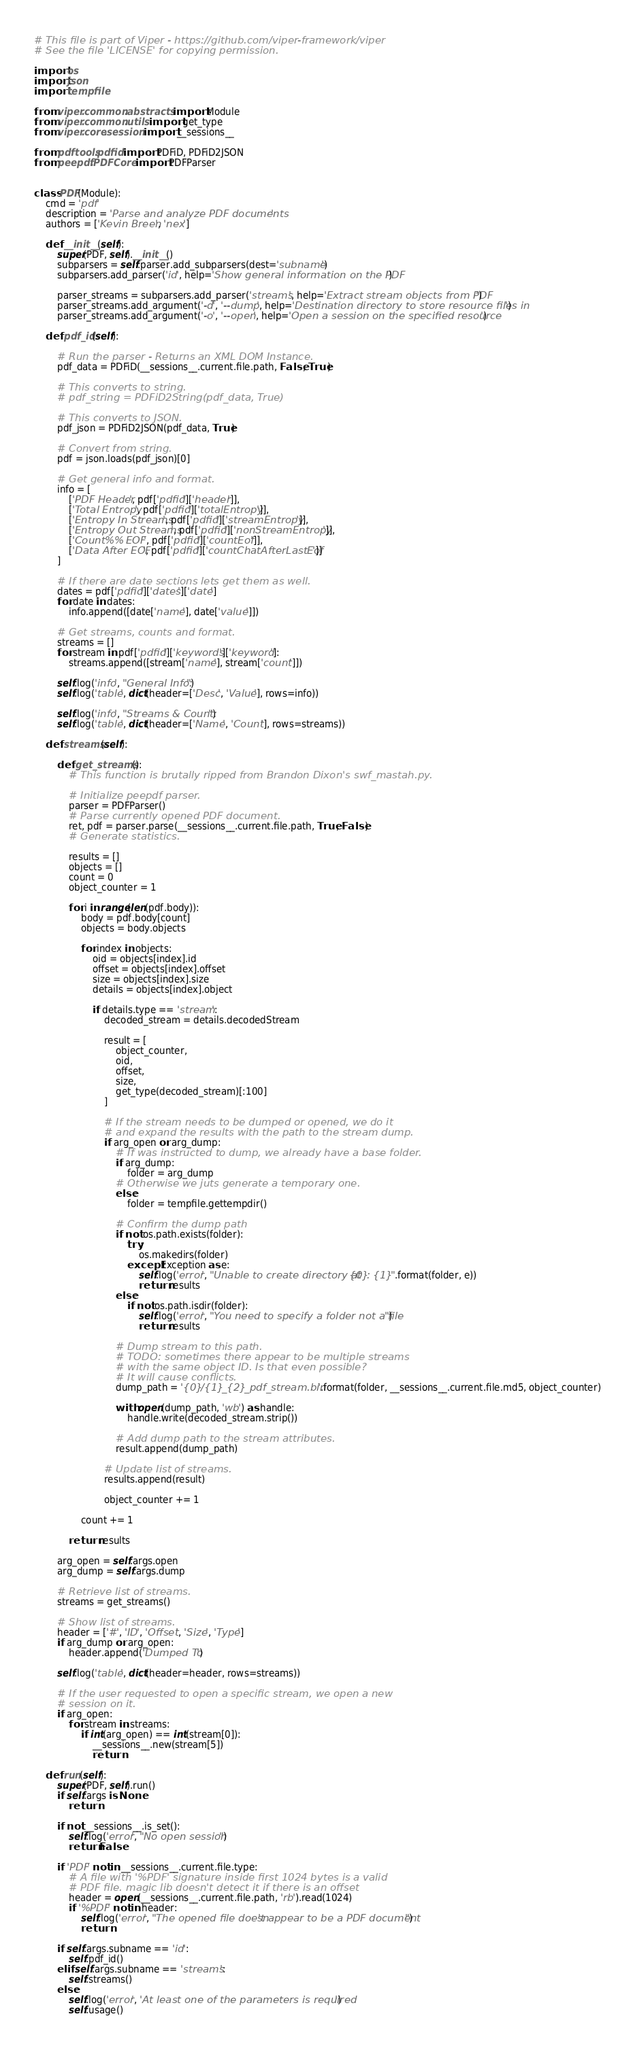Convert code to text. <code><loc_0><loc_0><loc_500><loc_500><_Python_># This file is part of Viper - https://github.com/viper-framework/viper
# See the file 'LICENSE' for copying permission.

import os
import json
import tempfile

from viper.common.abstracts import Module
from viper.common.utils import get_type
from viper.core.session import __sessions__

from pdftools.pdfid import PDFiD, PDFiD2JSON
from peepdf.PDFCore import PDFParser


class PDF(Module):
    cmd = 'pdf'
    description = 'Parse and analyze PDF documents'
    authors = ['Kevin Breen', 'nex']

    def __init__(self):
        super(PDF, self).__init__()
        subparsers = self.parser.add_subparsers(dest='subname')
        subparsers.add_parser('id', help='Show general information on the PDF')

        parser_streams = subparsers.add_parser('streams', help='Extract stream objects from PDF')
        parser_streams.add_argument('-d', '--dump', help='Destination directory to store resource files in')
        parser_streams.add_argument('-o', '--open', help='Open a session on the specified resource')

    def pdf_id(self):

        # Run the parser - Returns an XML DOM Instance.
        pdf_data = PDFiD(__sessions__.current.file.path, False, True)

        # This converts to string.
        # pdf_string = PDFiD2String(pdf_data, True)

        # This converts to JSON.
        pdf_json = PDFiD2JSON(pdf_data, True)

        # Convert from string.
        pdf = json.loads(pdf_json)[0]

        # Get general info and format.
        info = [
            ['PDF Header', pdf['pdfid']['header']],
            ['Total Entropy', pdf['pdfid']['totalEntropy']],
            ['Entropy In Streams', pdf['pdfid']['streamEntropy']],
            ['Entropy Out Streams', pdf['pdfid']['nonStreamEntropy']],
            ['Count %% EOF', pdf['pdfid']['countEof']],
            ['Data After EOF', pdf['pdfid']['countChatAfterLastEof']]
        ]

        # If there are date sections lets get them as well.
        dates = pdf['pdfid']['dates']['date']
        for date in dates:
            info.append([date['name'], date['value']])

        # Get streams, counts and format.
        streams = []
        for stream in pdf['pdfid']['keywords']['keyword']:
            streams.append([stream['name'], stream['count']])

        self.log('info', "General Info:")
        self.log('table', dict(header=['Desc', 'Value'], rows=info))

        self.log('info', "Streams & Count:")
        self.log('table', dict(header=['Name', 'Count'], rows=streams))

    def streams(self):

        def get_streams():
            # This function is brutally ripped from Brandon Dixon's swf_mastah.py.

            # Initialize peepdf parser.
            parser = PDFParser()
            # Parse currently opened PDF document.
            ret, pdf = parser.parse(__sessions__.current.file.path, True, False)
            # Generate statistics.

            results = []
            objects = []
            count = 0
            object_counter = 1

            for i in range(len(pdf.body)):
                body = pdf.body[count]
                objects = body.objects

                for index in objects:
                    oid = objects[index].id
                    offset = objects[index].offset
                    size = objects[index].size
                    details = objects[index].object

                    if details.type == 'stream':
                        decoded_stream = details.decodedStream

                        result = [
                            object_counter,
                            oid,
                            offset,
                            size,
                            get_type(decoded_stream)[:100]
                        ]

                        # If the stream needs to be dumped or opened, we do it
                        # and expand the results with the path to the stream dump.
                        if arg_open or arg_dump:
                            # If was instructed to dump, we already have a base folder.
                            if arg_dump:
                                folder = arg_dump
                            # Otherwise we juts generate a temporary one.
                            else:
                                folder = tempfile.gettempdir()

                            # Confirm the dump path
                            if not os.path.exists(folder):
                                try:
                                    os.makedirs(folder)
                                except Exception as e:
                                    self.log('error', "Unable to create directory at {0}: {1}".format(folder, e))
                                    return results
                            else:
                                if not os.path.isdir(folder):
                                    self.log('error', "You need to specify a folder not a file")
                                    return results

                            # Dump stream to this path.
                            # TODO: sometimes there appear to be multiple streams
                            # with the same object ID. Is that even possible?
                            # It will cause conflicts.
                            dump_path = '{0}/{1}_{2}_pdf_stream.bin'.format(folder, __sessions__.current.file.md5, object_counter)

                            with open(dump_path, 'wb') as handle:
                                handle.write(decoded_stream.strip())

                            # Add dump path to the stream attributes.
                            result.append(dump_path)

                        # Update list of streams.
                        results.append(result)

                        object_counter += 1

                count += 1

            return results

        arg_open = self.args.open
        arg_dump = self.args.dump

        # Retrieve list of streams.
        streams = get_streams()

        # Show list of streams.
        header = ['#', 'ID', 'Offset', 'Size', 'Type']
        if arg_dump or arg_open:
            header.append('Dumped To')

        self.log('table', dict(header=header, rows=streams))

        # If the user requested to open a specific stream, we open a new
        # session on it.
        if arg_open:
            for stream in streams:
                if int(arg_open) == int(stream[0]):
                    __sessions__.new(stream[5])
                    return

    def run(self):
        super(PDF, self).run()
        if self.args is None:
            return

        if not __sessions__.is_set():
            self.log('error', "No open session")
            return False

        if 'PDF' not in __sessions__.current.file.type:
            # A file with '%PDF' signature inside first 1024 bytes is a valid
            # PDF file. magic lib doesn't detect it if there is an offset
            header = open(__sessions__.current.file.path, 'rb').read(1024)
            if '%PDF' not in header:
                self.log('error', "The opened file doesn't appear to be a PDF document")
                return

        if self.args.subname == 'id':
            self.pdf_id()
        elif self.args.subname == 'streams':
            self.streams()
        else:
            self.log('error', 'At least one of the parameters is required')
            self.usage()
</code> 